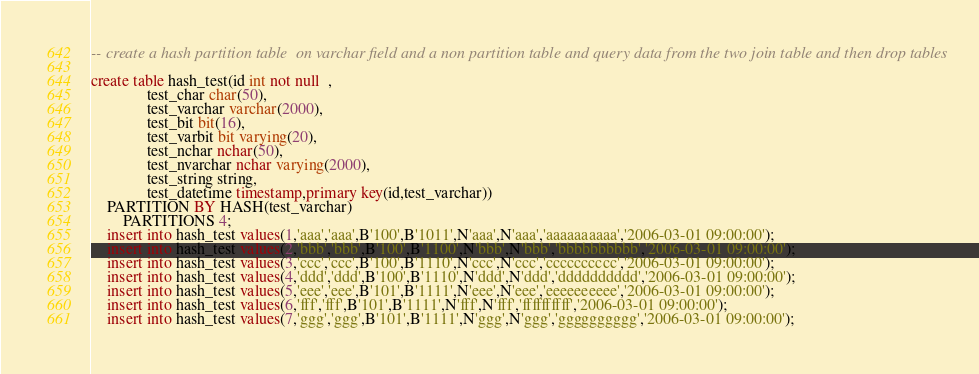Convert code to text. <code><loc_0><loc_0><loc_500><loc_500><_SQL_>-- create a hash partition table  on varchar field and a non partition table and query data from the two join table and then drop tables

create table hash_test(id int not null  ,
			  test_char char(50),
			  test_varchar varchar(2000),
			  test_bit bit(16),
			  test_varbit bit varying(20),
			  test_nchar nchar(50),
			  test_nvarchar nchar varying(2000),
			  test_string string,
			  test_datetime timestamp,primary key(id,test_varchar))
	PARTITION BY HASH(test_varchar)
        PARTITIONS 4;
	insert into hash_test values(1,'aaa','aaa',B'100',B'1011',N'aaa',N'aaa','aaaaaaaaaa','2006-03-01 09:00:00');
	insert into hash_test values(2,'bbb','bbb',B'100',B'1100',N'bbb',N'bbb','bbbbbbbbbb','2006-03-01 09:00:00');
	insert into hash_test values(3,'ccc','ccc',B'100',B'1110',N'ccc',N'ccc','cccccccccc','2006-03-01 09:00:00');
	insert into hash_test values(4,'ddd','ddd',B'100',B'1110',N'ddd',N'ddd','dddddddddd','2006-03-01 09:00:00');
	insert into hash_test values(5,'eee','eee',B'101',B'1111',N'eee',N'eee','eeeeeeeeee','2006-03-01 09:00:00');
	insert into hash_test values(6,'fff','fff',B'101',B'1111',N'fff',N'fff','ffffffffff','2006-03-01 09:00:00');
	insert into hash_test values(7,'ggg','ggg',B'101',B'1111',N'ggg',N'ggg','gggggggggg','2006-03-01 09:00:00');</code> 